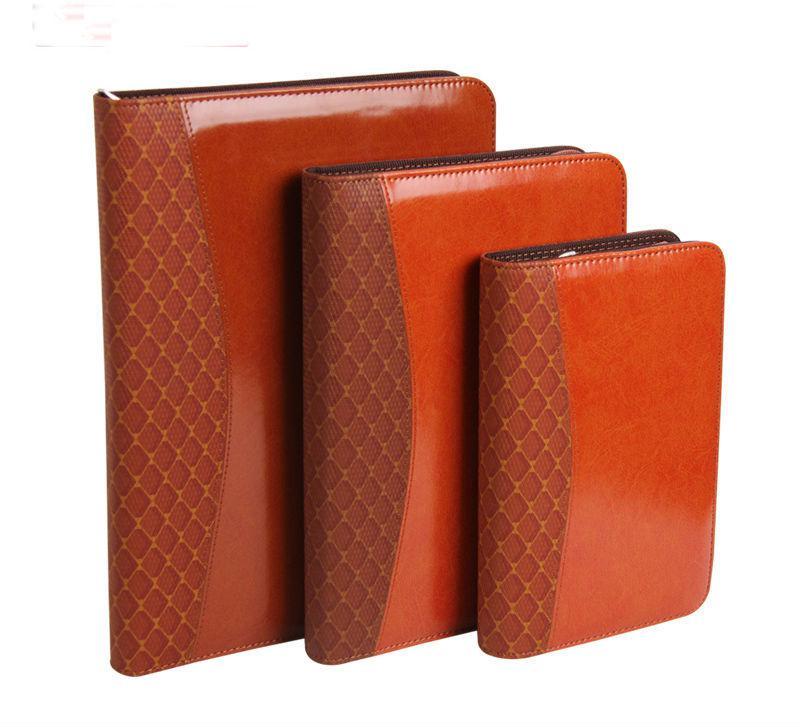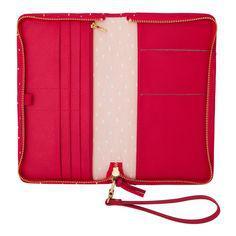The first image is the image on the left, the second image is the image on the right. Given the left and right images, does the statement "In total, four binders are shown." hold true? Answer yes or no. Yes. 